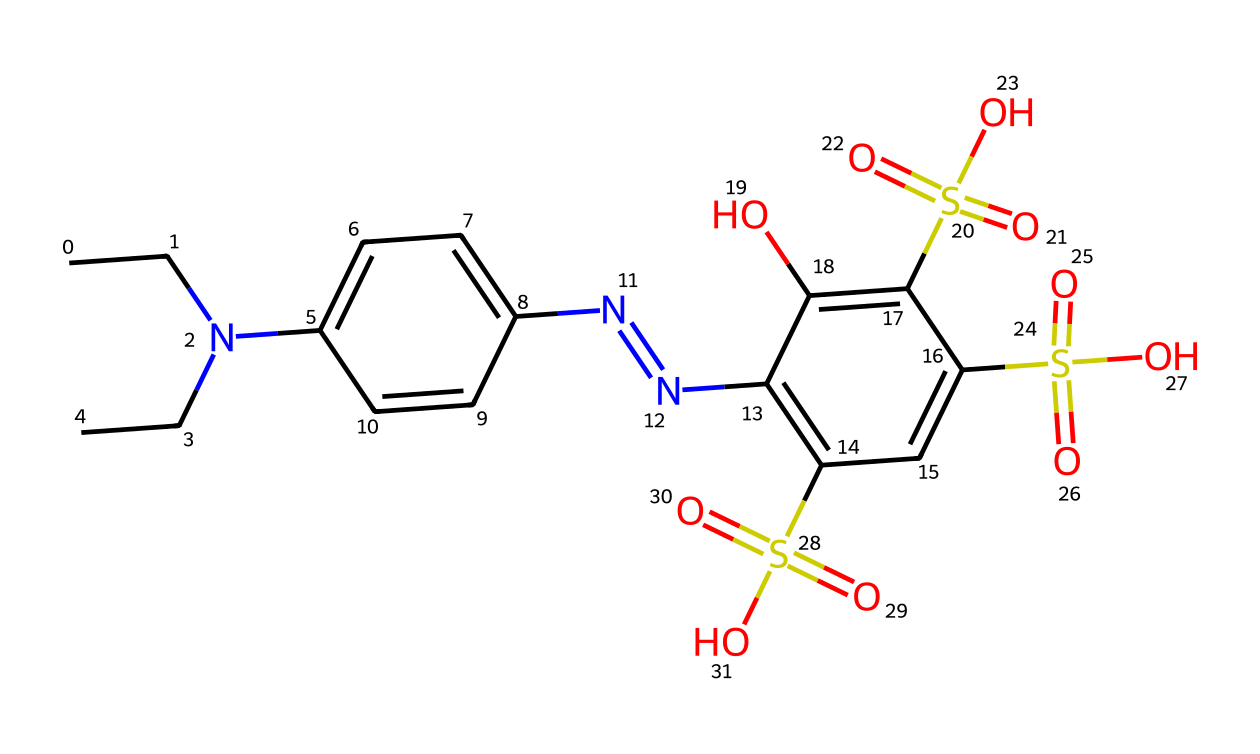What is the main functional group present in this chemical? The chemical structure shows the presence of multiple sulfonic acid groups (-SO3H) indicated by the "S(=O)(=O)O" segments. These are characteristic of sulfonates.
Answer: sulfonic acid How many nitrogen atoms are present in the structure? By examining the chemical, we can identify a total of three nitrogen atoms, which can be observed in the amine and azo groups.
Answer: three What is the total number of sulfur atoms in the molecule? The structure includes three instances of sulfur represented as "S(=O)(=O)O," which indicates three sulfur atoms embedded within the sulfonic acid groups.
Answer: three Which part of the chemical structure contributes to its color properties? The azo bond "N=N" is key for color properties in dye chemistry, allowing compounds to absorb visible light, thus contributing to the coloring capability.
Answer: azo bond What type of molecule is this chemical commonly classified as? Given the presence of various functional groups alongside the azo bond, this compound is classified as an azo dye, which is a common type of food coloring agent.
Answer: azo dye 